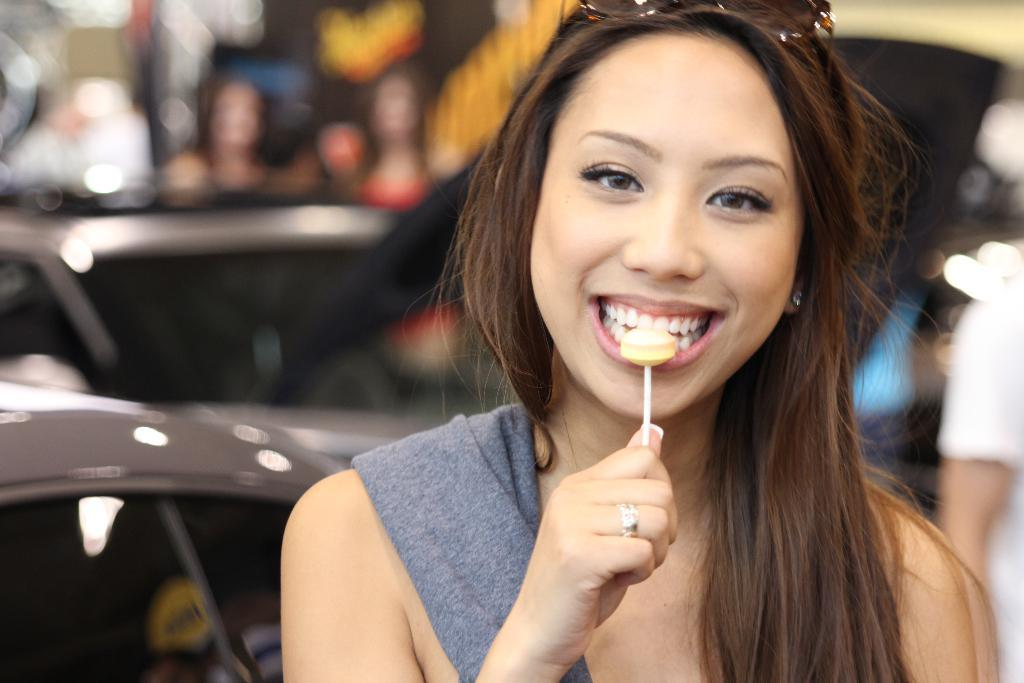Who is in the image? There is a woman in the image. What is the woman doing in the image? The woman is smiling in the image. What is the woman holding in the image? The woman is holding a lollipop in the image. What can be seen in the background of the image? There are vehicles, people, and some objects in the background of the image. How is the background of the image depicted? The background is blurry in the image. What type of curve can be seen on the pear in the image? There is no pear present in the image, so it is not possible to determine the type of curve on a pear. 